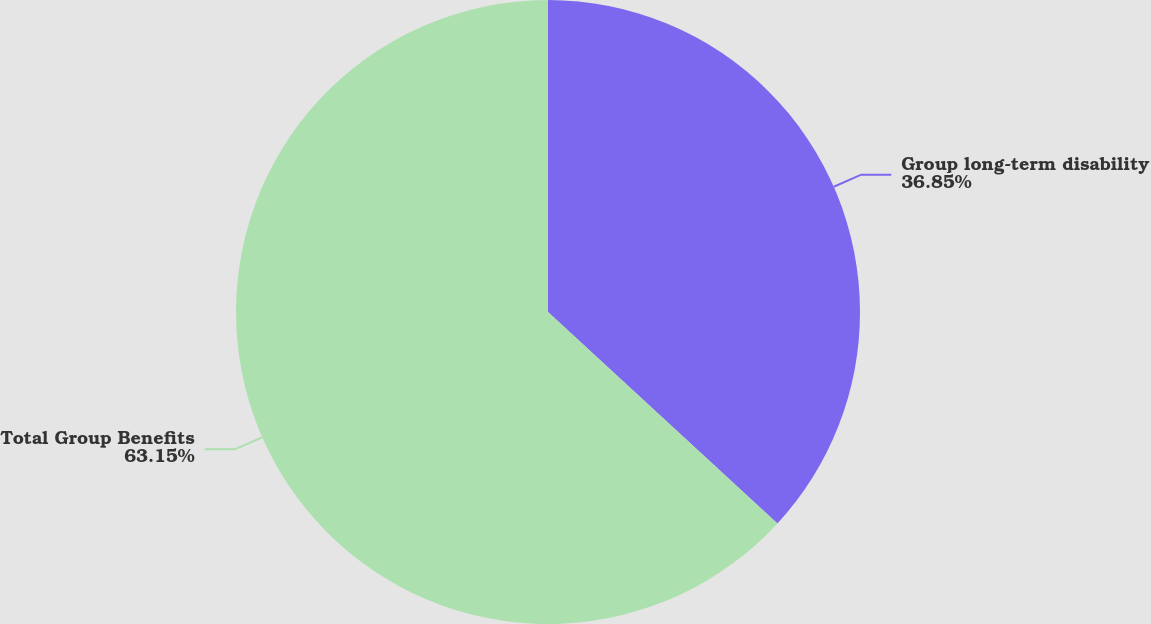<chart> <loc_0><loc_0><loc_500><loc_500><pie_chart><fcel>Group long-term disability<fcel>Total Group Benefits<nl><fcel>36.85%<fcel>63.15%<nl></chart> 